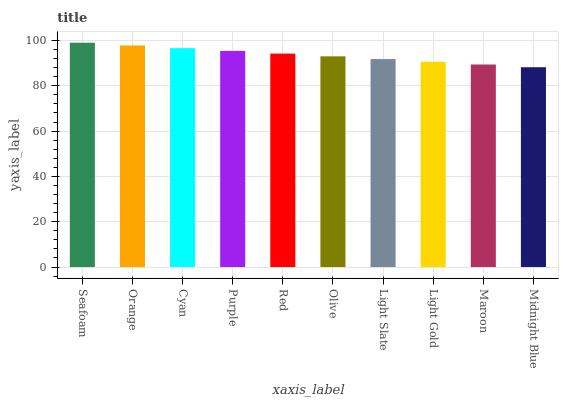Is Midnight Blue the minimum?
Answer yes or no. Yes. Is Seafoam the maximum?
Answer yes or no. Yes. Is Orange the minimum?
Answer yes or no. No. Is Orange the maximum?
Answer yes or no. No. Is Seafoam greater than Orange?
Answer yes or no. Yes. Is Orange less than Seafoam?
Answer yes or no. Yes. Is Orange greater than Seafoam?
Answer yes or no. No. Is Seafoam less than Orange?
Answer yes or no. No. Is Red the high median?
Answer yes or no. Yes. Is Olive the low median?
Answer yes or no. Yes. Is Olive the high median?
Answer yes or no. No. Is Midnight Blue the low median?
Answer yes or no. No. 